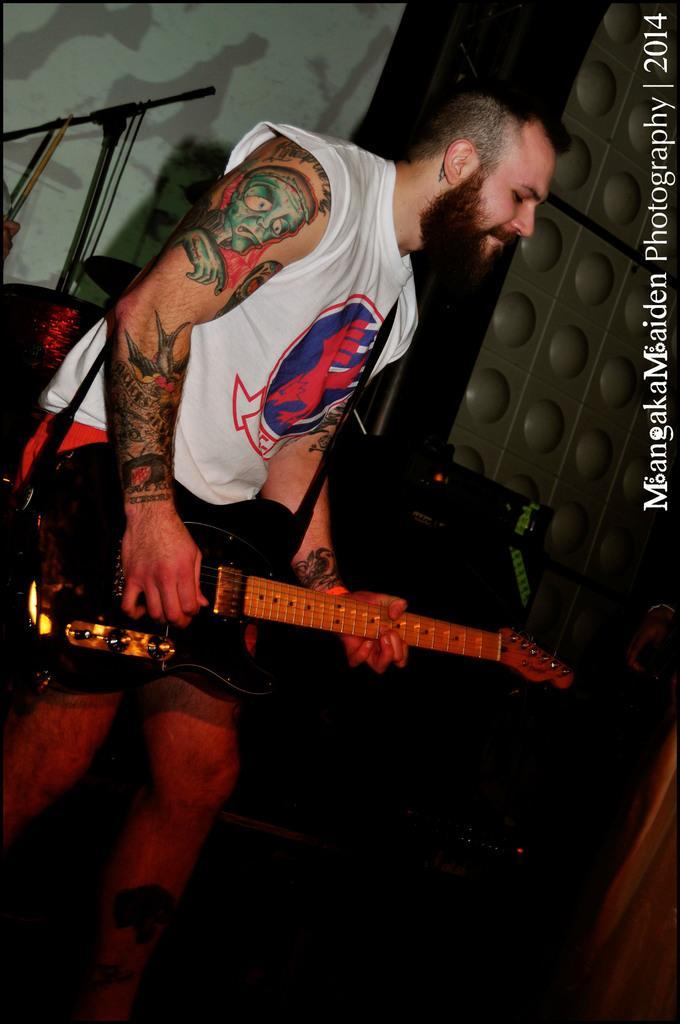Please provide a concise description of this image. This image is clicked in musical concert. There is a person in this image, he is holding guitar and playing it. Behind him there are drums and drumsticks. There is a screen behind him. He wore white color shirt and black color short. 